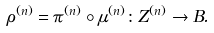<formula> <loc_0><loc_0><loc_500><loc_500>\rho ^ { ( n ) } = \pi ^ { ( n ) } \circ \mu ^ { ( n ) } \colon Z ^ { ( n ) } \to B .</formula> 